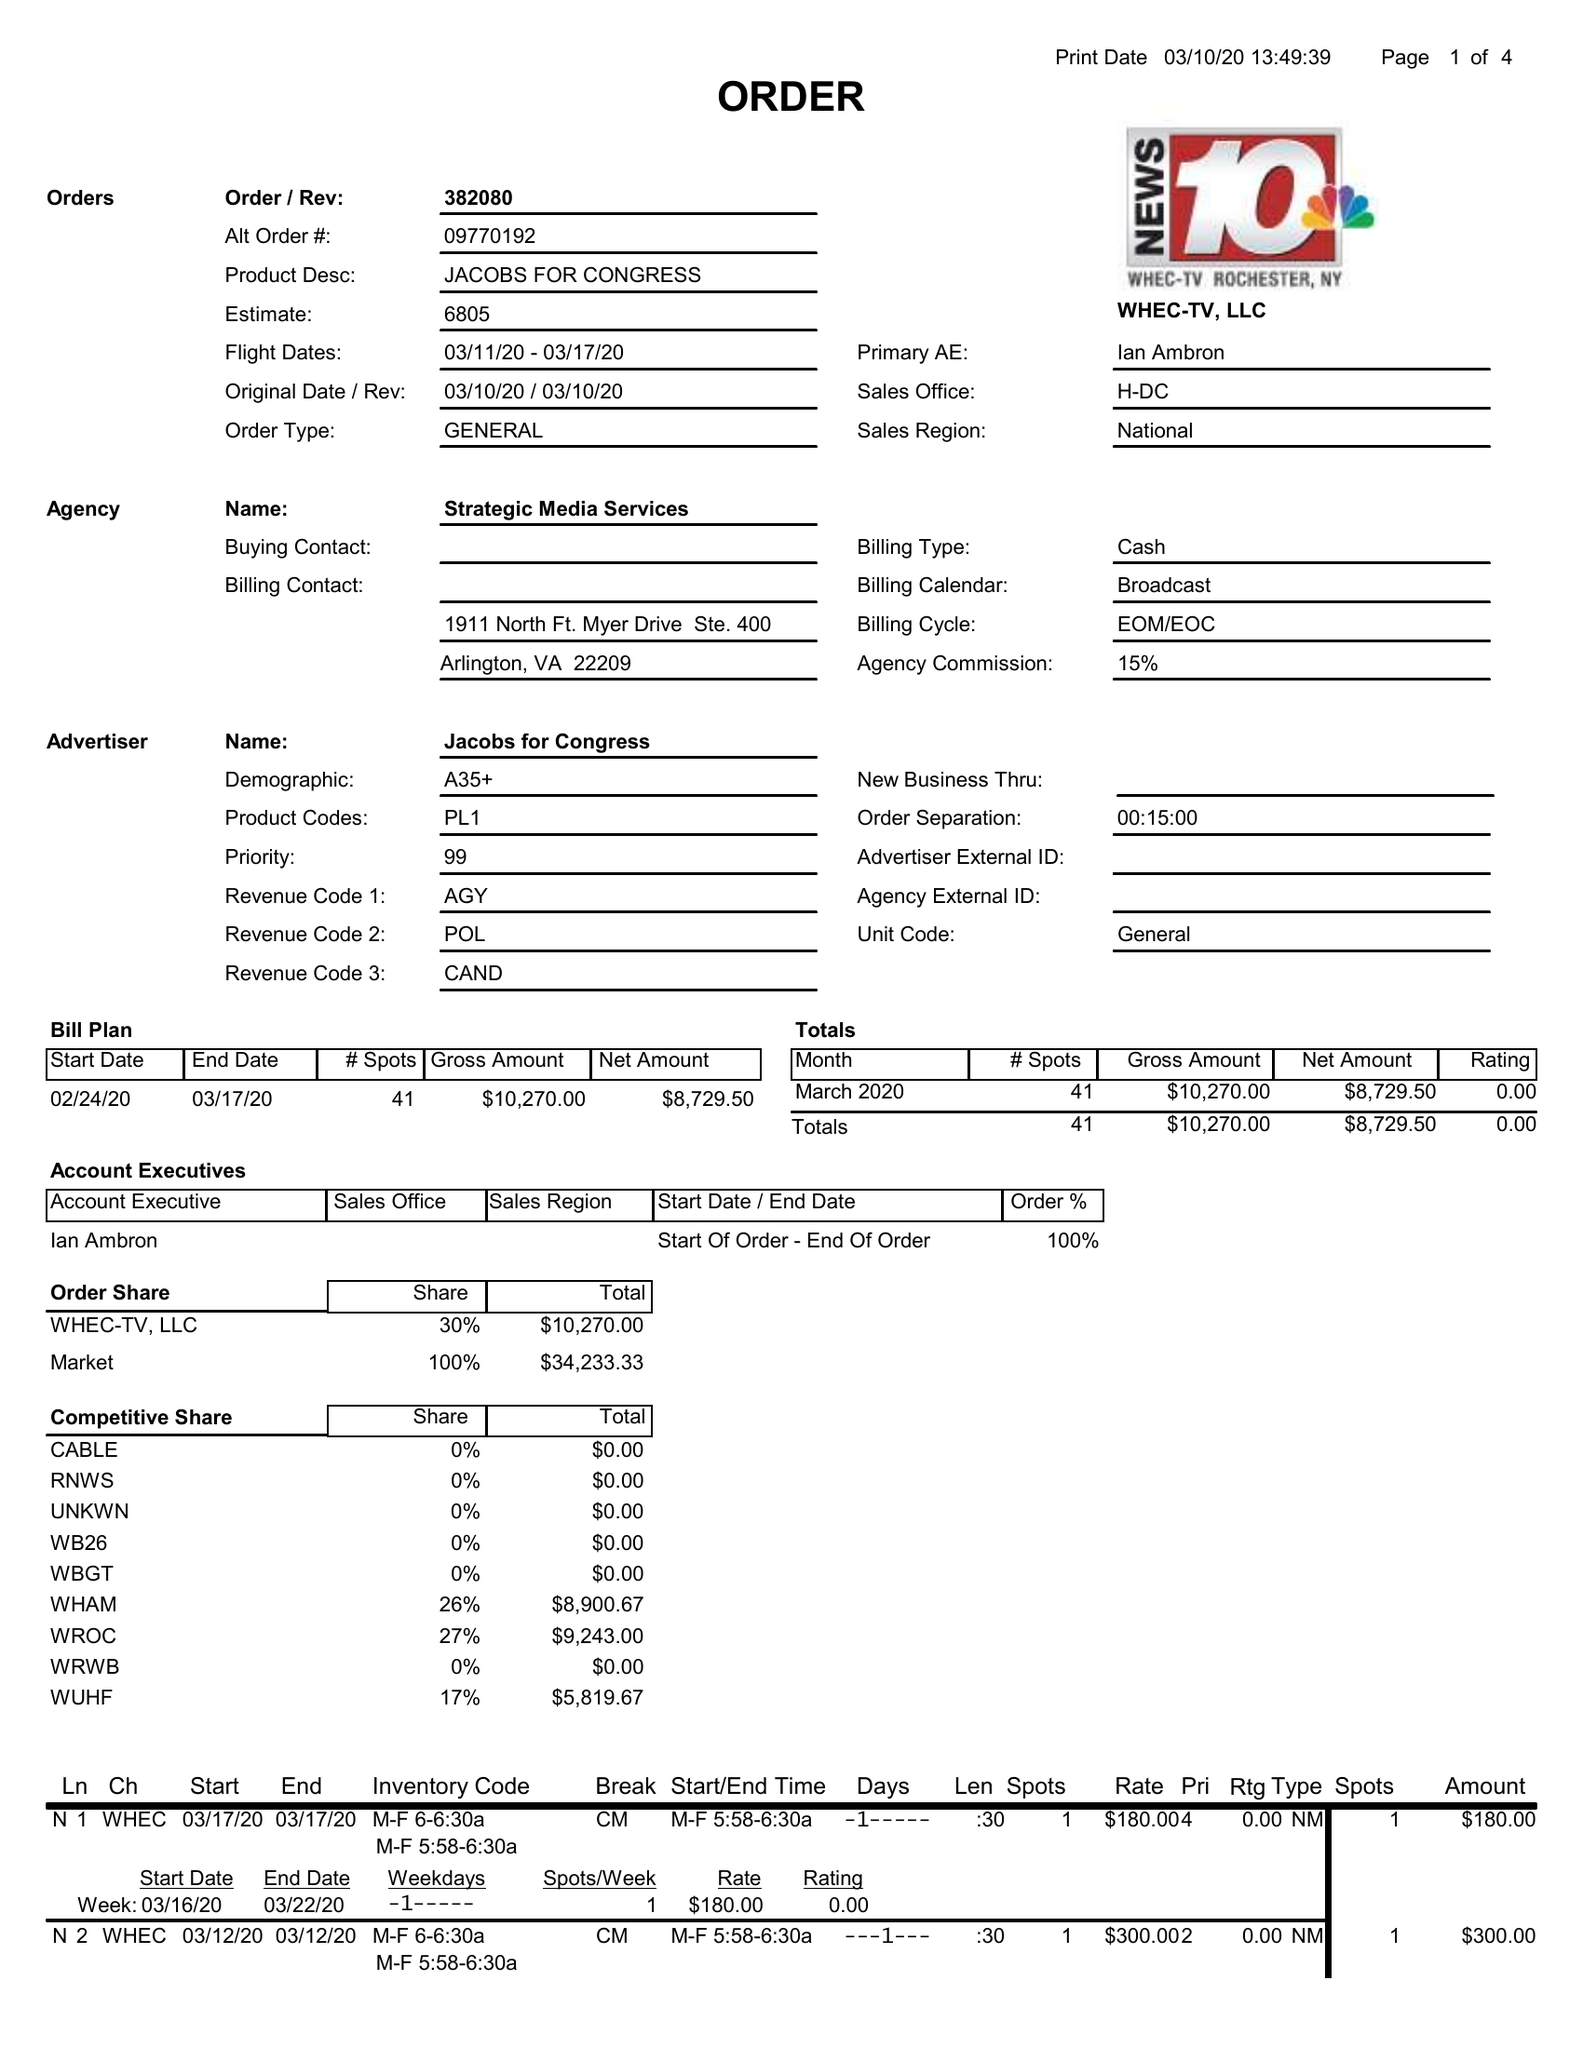What is the value for the gross_amount?
Answer the question using a single word or phrase. 10270.00 